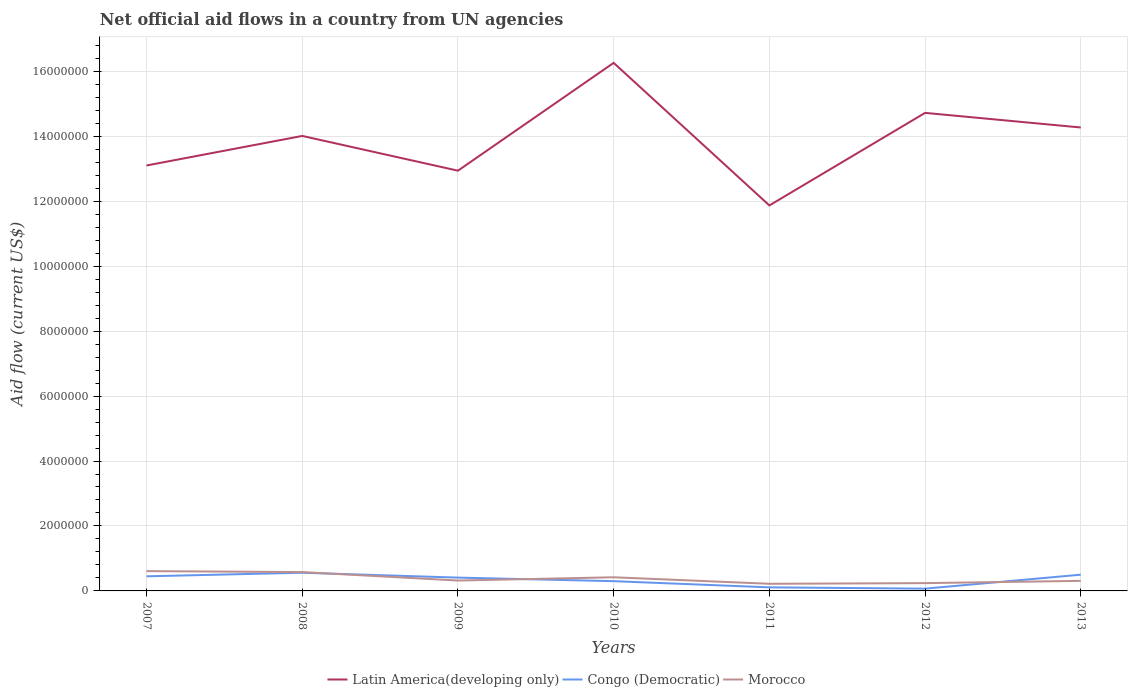Across all years, what is the maximum net official aid flow in Morocco?
Your response must be concise. 2.20e+05. What is the total net official aid flow in Latin America(developing only) in the graph?
Your response must be concise. 4.50e+05. What is the difference between the highest and the second highest net official aid flow in Congo (Democratic)?
Make the answer very short. 4.90e+05. What is the difference between the highest and the lowest net official aid flow in Latin America(developing only)?
Make the answer very short. 4. How many years are there in the graph?
Your answer should be very brief. 7. What is the difference between two consecutive major ticks on the Y-axis?
Your answer should be compact. 2.00e+06. Are the values on the major ticks of Y-axis written in scientific E-notation?
Ensure brevity in your answer.  No. Does the graph contain grids?
Keep it short and to the point. Yes. Where does the legend appear in the graph?
Offer a very short reply. Bottom center. What is the title of the graph?
Your answer should be very brief. Net official aid flows in a country from UN agencies. What is the label or title of the X-axis?
Provide a succinct answer. Years. What is the Aid flow (current US$) of Latin America(developing only) in 2007?
Your response must be concise. 1.31e+07. What is the Aid flow (current US$) in Latin America(developing only) in 2008?
Give a very brief answer. 1.40e+07. What is the Aid flow (current US$) in Congo (Democratic) in 2008?
Ensure brevity in your answer.  5.60e+05. What is the Aid flow (current US$) in Morocco in 2008?
Your response must be concise. 5.80e+05. What is the Aid flow (current US$) in Latin America(developing only) in 2009?
Offer a terse response. 1.29e+07. What is the Aid flow (current US$) in Latin America(developing only) in 2010?
Provide a short and direct response. 1.63e+07. What is the Aid flow (current US$) of Congo (Democratic) in 2010?
Offer a very short reply. 3.00e+05. What is the Aid flow (current US$) of Morocco in 2010?
Ensure brevity in your answer.  4.20e+05. What is the Aid flow (current US$) in Latin America(developing only) in 2011?
Your answer should be compact. 1.19e+07. What is the Aid flow (current US$) of Latin America(developing only) in 2012?
Provide a succinct answer. 1.47e+07. What is the Aid flow (current US$) in Latin America(developing only) in 2013?
Offer a terse response. 1.43e+07. What is the Aid flow (current US$) in Morocco in 2013?
Provide a short and direct response. 3.10e+05. Across all years, what is the maximum Aid flow (current US$) of Latin America(developing only)?
Offer a terse response. 1.63e+07. Across all years, what is the maximum Aid flow (current US$) of Congo (Democratic)?
Your response must be concise. 5.60e+05. Across all years, what is the maximum Aid flow (current US$) in Morocco?
Your answer should be very brief. 6.10e+05. Across all years, what is the minimum Aid flow (current US$) in Latin America(developing only)?
Provide a short and direct response. 1.19e+07. Across all years, what is the minimum Aid flow (current US$) of Congo (Democratic)?
Your answer should be compact. 7.00e+04. What is the total Aid flow (current US$) in Latin America(developing only) in the graph?
Offer a terse response. 9.72e+07. What is the total Aid flow (current US$) of Congo (Democratic) in the graph?
Ensure brevity in your answer.  2.40e+06. What is the total Aid flow (current US$) in Morocco in the graph?
Provide a succinct answer. 2.70e+06. What is the difference between the Aid flow (current US$) of Latin America(developing only) in 2007 and that in 2008?
Your answer should be very brief. -9.10e+05. What is the difference between the Aid flow (current US$) of Congo (Democratic) in 2007 and that in 2008?
Offer a very short reply. -1.10e+05. What is the difference between the Aid flow (current US$) in Morocco in 2007 and that in 2008?
Make the answer very short. 3.00e+04. What is the difference between the Aid flow (current US$) in Morocco in 2007 and that in 2009?
Offer a terse response. 2.90e+05. What is the difference between the Aid flow (current US$) of Latin America(developing only) in 2007 and that in 2010?
Ensure brevity in your answer.  -3.16e+06. What is the difference between the Aid flow (current US$) of Morocco in 2007 and that in 2010?
Your answer should be very brief. 1.90e+05. What is the difference between the Aid flow (current US$) in Latin America(developing only) in 2007 and that in 2011?
Offer a very short reply. 1.23e+06. What is the difference between the Aid flow (current US$) in Morocco in 2007 and that in 2011?
Give a very brief answer. 3.90e+05. What is the difference between the Aid flow (current US$) of Latin America(developing only) in 2007 and that in 2012?
Offer a very short reply. -1.62e+06. What is the difference between the Aid flow (current US$) of Morocco in 2007 and that in 2012?
Your answer should be very brief. 3.70e+05. What is the difference between the Aid flow (current US$) in Latin America(developing only) in 2007 and that in 2013?
Offer a very short reply. -1.17e+06. What is the difference between the Aid flow (current US$) of Latin America(developing only) in 2008 and that in 2009?
Ensure brevity in your answer.  1.07e+06. What is the difference between the Aid flow (current US$) of Congo (Democratic) in 2008 and that in 2009?
Ensure brevity in your answer.  1.50e+05. What is the difference between the Aid flow (current US$) in Morocco in 2008 and that in 2009?
Your answer should be compact. 2.60e+05. What is the difference between the Aid flow (current US$) in Latin America(developing only) in 2008 and that in 2010?
Make the answer very short. -2.25e+06. What is the difference between the Aid flow (current US$) of Congo (Democratic) in 2008 and that in 2010?
Provide a succinct answer. 2.60e+05. What is the difference between the Aid flow (current US$) in Morocco in 2008 and that in 2010?
Keep it short and to the point. 1.60e+05. What is the difference between the Aid flow (current US$) in Latin America(developing only) in 2008 and that in 2011?
Your response must be concise. 2.14e+06. What is the difference between the Aid flow (current US$) in Congo (Democratic) in 2008 and that in 2011?
Provide a short and direct response. 4.50e+05. What is the difference between the Aid flow (current US$) in Morocco in 2008 and that in 2011?
Offer a very short reply. 3.60e+05. What is the difference between the Aid flow (current US$) of Latin America(developing only) in 2008 and that in 2012?
Your response must be concise. -7.10e+05. What is the difference between the Aid flow (current US$) of Congo (Democratic) in 2008 and that in 2013?
Your answer should be compact. 6.00e+04. What is the difference between the Aid flow (current US$) in Morocco in 2008 and that in 2013?
Your answer should be compact. 2.70e+05. What is the difference between the Aid flow (current US$) in Latin America(developing only) in 2009 and that in 2010?
Provide a short and direct response. -3.32e+06. What is the difference between the Aid flow (current US$) of Latin America(developing only) in 2009 and that in 2011?
Make the answer very short. 1.07e+06. What is the difference between the Aid flow (current US$) of Latin America(developing only) in 2009 and that in 2012?
Your response must be concise. -1.78e+06. What is the difference between the Aid flow (current US$) in Latin America(developing only) in 2009 and that in 2013?
Provide a short and direct response. -1.33e+06. What is the difference between the Aid flow (current US$) in Congo (Democratic) in 2009 and that in 2013?
Your answer should be compact. -9.00e+04. What is the difference between the Aid flow (current US$) of Latin America(developing only) in 2010 and that in 2011?
Your answer should be compact. 4.39e+06. What is the difference between the Aid flow (current US$) in Morocco in 2010 and that in 2011?
Make the answer very short. 2.00e+05. What is the difference between the Aid flow (current US$) in Latin America(developing only) in 2010 and that in 2012?
Your response must be concise. 1.54e+06. What is the difference between the Aid flow (current US$) of Morocco in 2010 and that in 2012?
Offer a very short reply. 1.80e+05. What is the difference between the Aid flow (current US$) of Latin America(developing only) in 2010 and that in 2013?
Offer a very short reply. 1.99e+06. What is the difference between the Aid flow (current US$) in Congo (Democratic) in 2010 and that in 2013?
Ensure brevity in your answer.  -2.00e+05. What is the difference between the Aid flow (current US$) in Morocco in 2010 and that in 2013?
Your answer should be very brief. 1.10e+05. What is the difference between the Aid flow (current US$) in Latin America(developing only) in 2011 and that in 2012?
Give a very brief answer. -2.85e+06. What is the difference between the Aid flow (current US$) in Congo (Democratic) in 2011 and that in 2012?
Ensure brevity in your answer.  4.00e+04. What is the difference between the Aid flow (current US$) of Morocco in 2011 and that in 2012?
Your answer should be very brief. -2.00e+04. What is the difference between the Aid flow (current US$) of Latin America(developing only) in 2011 and that in 2013?
Offer a terse response. -2.40e+06. What is the difference between the Aid flow (current US$) in Congo (Democratic) in 2011 and that in 2013?
Keep it short and to the point. -3.90e+05. What is the difference between the Aid flow (current US$) of Morocco in 2011 and that in 2013?
Your response must be concise. -9.00e+04. What is the difference between the Aid flow (current US$) in Latin America(developing only) in 2012 and that in 2013?
Keep it short and to the point. 4.50e+05. What is the difference between the Aid flow (current US$) of Congo (Democratic) in 2012 and that in 2013?
Give a very brief answer. -4.30e+05. What is the difference between the Aid flow (current US$) in Morocco in 2012 and that in 2013?
Provide a succinct answer. -7.00e+04. What is the difference between the Aid flow (current US$) in Latin America(developing only) in 2007 and the Aid flow (current US$) in Congo (Democratic) in 2008?
Your answer should be very brief. 1.25e+07. What is the difference between the Aid flow (current US$) in Latin America(developing only) in 2007 and the Aid flow (current US$) in Morocco in 2008?
Give a very brief answer. 1.25e+07. What is the difference between the Aid flow (current US$) of Congo (Democratic) in 2007 and the Aid flow (current US$) of Morocco in 2008?
Provide a short and direct response. -1.30e+05. What is the difference between the Aid flow (current US$) of Latin America(developing only) in 2007 and the Aid flow (current US$) of Congo (Democratic) in 2009?
Provide a succinct answer. 1.27e+07. What is the difference between the Aid flow (current US$) in Latin America(developing only) in 2007 and the Aid flow (current US$) in Morocco in 2009?
Make the answer very short. 1.28e+07. What is the difference between the Aid flow (current US$) in Congo (Democratic) in 2007 and the Aid flow (current US$) in Morocco in 2009?
Offer a terse response. 1.30e+05. What is the difference between the Aid flow (current US$) of Latin America(developing only) in 2007 and the Aid flow (current US$) of Congo (Democratic) in 2010?
Make the answer very short. 1.28e+07. What is the difference between the Aid flow (current US$) in Latin America(developing only) in 2007 and the Aid flow (current US$) in Morocco in 2010?
Provide a succinct answer. 1.27e+07. What is the difference between the Aid flow (current US$) of Congo (Democratic) in 2007 and the Aid flow (current US$) of Morocco in 2010?
Offer a terse response. 3.00e+04. What is the difference between the Aid flow (current US$) in Latin America(developing only) in 2007 and the Aid flow (current US$) in Congo (Democratic) in 2011?
Your answer should be compact. 1.30e+07. What is the difference between the Aid flow (current US$) of Latin America(developing only) in 2007 and the Aid flow (current US$) of Morocco in 2011?
Your response must be concise. 1.29e+07. What is the difference between the Aid flow (current US$) in Latin America(developing only) in 2007 and the Aid flow (current US$) in Congo (Democratic) in 2012?
Provide a succinct answer. 1.30e+07. What is the difference between the Aid flow (current US$) of Latin America(developing only) in 2007 and the Aid flow (current US$) of Morocco in 2012?
Provide a short and direct response. 1.29e+07. What is the difference between the Aid flow (current US$) in Congo (Democratic) in 2007 and the Aid flow (current US$) in Morocco in 2012?
Your response must be concise. 2.10e+05. What is the difference between the Aid flow (current US$) of Latin America(developing only) in 2007 and the Aid flow (current US$) of Congo (Democratic) in 2013?
Keep it short and to the point. 1.26e+07. What is the difference between the Aid flow (current US$) in Latin America(developing only) in 2007 and the Aid flow (current US$) in Morocco in 2013?
Offer a very short reply. 1.28e+07. What is the difference between the Aid flow (current US$) of Congo (Democratic) in 2007 and the Aid flow (current US$) of Morocco in 2013?
Offer a very short reply. 1.40e+05. What is the difference between the Aid flow (current US$) in Latin America(developing only) in 2008 and the Aid flow (current US$) in Congo (Democratic) in 2009?
Offer a very short reply. 1.36e+07. What is the difference between the Aid flow (current US$) of Latin America(developing only) in 2008 and the Aid flow (current US$) of Morocco in 2009?
Keep it short and to the point. 1.37e+07. What is the difference between the Aid flow (current US$) in Latin America(developing only) in 2008 and the Aid flow (current US$) in Congo (Democratic) in 2010?
Keep it short and to the point. 1.37e+07. What is the difference between the Aid flow (current US$) in Latin America(developing only) in 2008 and the Aid flow (current US$) in Morocco in 2010?
Make the answer very short. 1.36e+07. What is the difference between the Aid flow (current US$) of Latin America(developing only) in 2008 and the Aid flow (current US$) of Congo (Democratic) in 2011?
Your response must be concise. 1.39e+07. What is the difference between the Aid flow (current US$) of Latin America(developing only) in 2008 and the Aid flow (current US$) of Morocco in 2011?
Make the answer very short. 1.38e+07. What is the difference between the Aid flow (current US$) in Congo (Democratic) in 2008 and the Aid flow (current US$) in Morocco in 2011?
Your answer should be compact. 3.40e+05. What is the difference between the Aid flow (current US$) of Latin America(developing only) in 2008 and the Aid flow (current US$) of Congo (Democratic) in 2012?
Give a very brief answer. 1.39e+07. What is the difference between the Aid flow (current US$) in Latin America(developing only) in 2008 and the Aid flow (current US$) in Morocco in 2012?
Offer a very short reply. 1.38e+07. What is the difference between the Aid flow (current US$) of Latin America(developing only) in 2008 and the Aid flow (current US$) of Congo (Democratic) in 2013?
Provide a short and direct response. 1.35e+07. What is the difference between the Aid flow (current US$) of Latin America(developing only) in 2008 and the Aid flow (current US$) of Morocco in 2013?
Your answer should be compact. 1.37e+07. What is the difference between the Aid flow (current US$) in Latin America(developing only) in 2009 and the Aid flow (current US$) in Congo (Democratic) in 2010?
Your answer should be compact. 1.26e+07. What is the difference between the Aid flow (current US$) of Latin America(developing only) in 2009 and the Aid flow (current US$) of Morocco in 2010?
Give a very brief answer. 1.25e+07. What is the difference between the Aid flow (current US$) of Latin America(developing only) in 2009 and the Aid flow (current US$) of Congo (Democratic) in 2011?
Your answer should be very brief. 1.28e+07. What is the difference between the Aid flow (current US$) in Latin America(developing only) in 2009 and the Aid flow (current US$) in Morocco in 2011?
Provide a short and direct response. 1.27e+07. What is the difference between the Aid flow (current US$) in Latin America(developing only) in 2009 and the Aid flow (current US$) in Congo (Democratic) in 2012?
Offer a terse response. 1.29e+07. What is the difference between the Aid flow (current US$) of Latin America(developing only) in 2009 and the Aid flow (current US$) of Morocco in 2012?
Keep it short and to the point. 1.27e+07. What is the difference between the Aid flow (current US$) in Latin America(developing only) in 2009 and the Aid flow (current US$) in Congo (Democratic) in 2013?
Offer a very short reply. 1.24e+07. What is the difference between the Aid flow (current US$) in Latin America(developing only) in 2009 and the Aid flow (current US$) in Morocco in 2013?
Make the answer very short. 1.26e+07. What is the difference between the Aid flow (current US$) in Latin America(developing only) in 2010 and the Aid flow (current US$) in Congo (Democratic) in 2011?
Offer a terse response. 1.62e+07. What is the difference between the Aid flow (current US$) of Latin America(developing only) in 2010 and the Aid flow (current US$) of Morocco in 2011?
Your response must be concise. 1.60e+07. What is the difference between the Aid flow (current US$) of Latin America(developing only) in 2010 and the Aid flow (current US$) of Congo (Democratic) in 2012?
Provide a succinct answer. 1.62e+07. What is the difference between the Aid flow (current US$) in Latin America(developing only) in 2010 and the Aid flow (current US$) in Morocco in 2012?
Your response must be concise. 1.60e+07. What is the difference between the Aid flow (current US$) of Congo (Democratic) in 2010 and the Aid flow (current US$) of Morocco in 2012?
Make the answer very short. 6.00e+04. What is the difference between the Aid flow (current US$) in Latin America(developing only) in 2010 and the Aid flow (current US$) in Congo (Democratic) in 2013?
Give a very brief answer. 1.58e+07. What is the difference between the Aid flow (current US$) of Latin America(developing only) in 2010 and the Aid flow (current US$) of Morocco in 2013?
Your response must be concise. 1.60e+07. What is the difference between the Aid flow (current US$) in Congo (Democratic) in 2010 and the Aid flow (current US$) in Morocco in 2013?
Provide a short and direct response. -10000. What is the difference between the Aid flow (current US$) of Latin America(developing only) in 2011 and the Aid flow (current US$) of Congo (Democratic) in 2012?
Ensure brevity in your answer.  1.18e+07. What is the difference between the Aid flow (current US$) of Latin America(developing only) in 2011 and the Aid flow (current US$) of Morocco in 2012?
Offer a terse response. 1.16e+07. What is the difference between the Aid flow (current US$) of Latin America(developing only) in 2011 and the Aid flow (current US$) of Congo (Democratic) in 2013?
Your answer should be very brief. 1.14e+07. What is the difference between the Aid flow (current US$) of Latin America(developing only) in 2011 and the Aid flow (current US$) of Morocco in 2013?
Offer a terse response. 1.16e+07. What is the difference between the Aid flow (current US$) in Congo (Democratic) in 2011 and the Aid flow (current US$) in Morocco in 2013?
Your answer should be very brief. -2.00e+05. What is the difference between the Aid flow (current US$) of Latin America(developing only) in 2012 and the Aid flow (current US$) of Congo (Democratic) in 2013?
Ensure brevity in your answer.  1.42e+07. What is the difference between the Aid flow (current US$) of Latin America(developing only) in 2012 and the Aid flow (current US$) of Morocco in 2013?
Your answer should be compact. 1.44e+07. What is the average Aid flow (current US$) in Latin America(developing only) per year?
Your answer should be compact. 1.39e+07. What is the average Aid flow (current US$) in Congo (Democratic) per year?
Your answer should be compact. 3.43e+05. What is the average Aid flow (current US$) in Morocco per year?
Offer a terse response. 3.86e+05. In the year 2007, what is the difference between the Aid flow (current US$) of Latin America(developing only) and Aid flow (current US$) of Congo (Democratic)?
Your response must be concise. 1.26e+07. In the year 2007, what is the difference between the Aid flow (current US$) of Latin America(developing only) and Aid flow (current US$) of Morocco?
Provide a short and direct response. 1.25e+07. In the year 2007, what is the difference between the Aid flow (current US$) in Congo (Democratic) and Aid flow (current US$) in Morocco?
Provide a short and direct response. -1.60e+05. In the year 2008, what is the difference between the Aid flow (current US$) of Latin America(developing only) and Aid flow (current US$) of Congo (Democratic)?
Offer a very short reply. 1.34e+07. In the year 2008, what is the difference between the Aid flow (current US$) of Latin America(developing only) and Aid flow (current US$) of Morocco?
Keep it short and to the point. 1.34e+07. In the year 2008, what is the difference between the Aid flow (current US$) in Congo (Democratic) and Aid flow (current US$) in Morocco?
Your answer should be very brief. -2.00e+04. In the year 2009, what is the difference between the Aid flow (current US$) in Latin America(developing only) and Aid flow (current US$) in Congo (Democratic)?
Keep it short and to the point. 1.25e+07. In the year 2009, what is the difference between the Aid flow (current US$) in Latin America(developing only) and Aid flow (current US$) in Morocco?
Provide a short and direct response. 1.26e+07. In the year 2010, what is the difference between the Aid flow (current US$) in Latin America(developing only) and Aid flow (current US$) in Congo (Democratic)?
Your answer should be very brief. 1.60e+07. In the year 2010, what is the difference between the Aid flow (current US$) of Latin America(developing only) and Aid flow (current US$) of Morocco?
Your response must be concise. 1.58e+07. In the year 2010, what is the difference between the Aid flow (current US$) in Congo (Democratic) and Aid flow (current US$) in Morocco?
Keep it short and to the point. -1.20e+05. In the year 2011, what is the difference between the Aid flow (current US$) of Latin America(developing only) and Aid flow (current US$) of Congo (Democratic)?
Your answer should be compact. 1.18e+07. In the year 2011, what is the difference between the Aid flow (current US$) in Latin America(developing only) and Aid flow (current US$) in Morocco?
Keep it short and to the point. 1.16e+07. In the year 2012, what is the difference between the Aid flow (current US$) in Latin America(developing only) and Aid flow (current US$) in Congo (Democratic)?
Offer a very short reply. 1.46e+07. In the year 2012, what is the difference between the Aid flow (current US$) in Latin America(developing only) and Aid flow (current US$) in Morocco?
Offer a terse response. 1.45e+07. In the year 2013, what is the difference between the Aid flow (current US$) in Latin America(developing only) and Aid flow (current US$) in Congo (Democratic)?
Keep it short and to the point. 1.38e+07. In the year 2013, what is the difference between the Aid flow (current US$) in Latin America(developing only) and Aid flow (current US$) in Morocco?
Ensure brevity in your answer.  1.40e+07. What is the ratio of the Aid flow (current US$) in Latin America(developing only) in 2007 to that in 2008?
Keep it short and to the point. 0.94. What is the ratio of the Aid flow (current US$) in Congo (Democratic) in 2007 to that in 2008?
Your answer should be compact. 0.8. What is the ratio of the Aid flow (current US$) in Morocco in 2007 to that in 2008?
Make the answer very short. 1.05. What is the ratio of the Aid flow (current US$) of Latin America(developing only) in 2007 to that in 2009?
Offer a terse response. 1.01. What is the ratio of the Aid flow (current US$) in Congo (Democratic) in 2007 to that in 2009?
Your answer should be compact. 1.1. What is the ratio of the Aid flow (current US$) in Morocco in 2007 to that in 2009?
Make the answer very short. 1.91. What is the ratio of the Aid flow (current US$) of Latin America(developing only) in 2007 to that in 2010?
Ensure brevity in your answer.  0.81. What is the ratio of the Aid flow (current US$) of Morocco in 2007 to that in 2010?
Your answer should be compact. 1.45. What is the ratio of the Aid flow (current US$) in Latin America(developing only) in 2007 to that in 2011?
Your answer should be compact. 1.1. What is the ratio of the Aid flow (current US$) in Congo (Democratic) in 2007 to that in 2011?
Give a very brief answer. 4.09. What is the ratio of the Aid flow (current US$) of Morocco in 2007 to that in 2011?
Make the answer very short. 2.77. What is the ratio of the Aid flow (current US$) in Latin America(developing only) in 2007 to that in 2012?
Ensure brevity in your answer.  0.89. What is the ratio of the Aid flow (current US$) in Congo (Democratic) in 2007 to that in 2012?
Ensure brevity in your answer.  6.43. What is the ratio of the Aid flow (current US$) in Morocco in 2007 to that in 2012?
Provide a short and direct response. 2.54. What is the ratio of the Aid flow (current US$) of Latin America(developing only) in 2007 to that in 2013?
Give a very brief answer. 0.92. What is the ratio of the Aid flow (current US$) in Morocco in 2007 to that in 2013?
Your answer should be very brief. 1.97. What is the ratio of the Aid flow (current US$) of Latin America(developing only) in 2008 to that in 2009?
Your answer should be very brief. 1.08. What is the ratio of the Aid flow (current US$) in Congo (Democratic) in 2008 to that in 2009?
Provide a short and direct response. 1.37. What is the ratio of the Aid flow (current US$) in Morocco in 2008 to that in 2009?
Make the answer very short. 1.81. What is the ratio of the Aid flow (current US$) in Latin America(developing only) in 2008 to that in 2010?
Offer a very short reply. 0.86. What is the ratio of the Aid flow (current US$) of Congo (Democratic) in 2008 to that in 2010?
Keep it short and to the point. 1.87. What is the ratio of the Aid flow (current US$) of Morocco in 2008 to that in 2010?
Give a very brief answer. 1.38. What is the ratio of the Aid flow (current US$) in Latin America(developing only) in 2008 to that in 2011?
Offer a terse response. 1.18. What is the ratio of the Aid flow (current US$) in Congo (Democratic) in 2008 to that in 2011?
Keep it short and to the point. 5.09. What is the ratio of the Aid flow (current US$) in Morocco in 2008 to that in 2011?
Provide a succinct answer. 2.64. What is the ratio of the Aid flow (current US$) of Latin America(developing only) in 2008 to that in 2012?
Give a very brief answer. 0.95. What is the ratio of the Aid flow (current US$) of Morocco in 2008 to that in 2012?
Offer a terse response. 2.42. What is the ratio of the Aid flow (current US$) of Latin America(developing only) in 2008 to that in 2013?
Ensure brevity in your answer.  0.98. What is the ratio of the Aid flow (current US$) in Congo (Democratic) in 2008 to that in 2013?
Keep it short and to the point. 1.12. What is the ratio of the Aid flow (current US$) of Morocco in 2008 to that in 2013?
Offer a terse response. 1.87. What is the ratio of the Aid flow (current US$) in Latin America(developing only) in 2009 to that in 2010?
Give a very brief answer. 0.8. What is the ratio of the Aid flow (current US$) of Congo (Democratic) in 2009 to that in 2010?
Keep it short and to the point. 1.37. What is the ratio of the Aid flow (current US$) in Morocco in 2009 to that in 2010?
Provide a succinct answer. 0.76. What is the ratio of the Aid flow (current US$) in Latin America(developing only) in 2009 to that in 2011?
Provide a succinct answer. 1.09. What is the ratio of the Aid flow (current US$) in Congo (Democratic) in 2009 to that in 2011?
Your response must be concise. 3.73. What is the ratio of the Aid flow (current US$) in Morocco in 2009 to that in 2011?
Ensure brevity in your answer.  1.45. What is the ratio of the Aid flow (current US$) in Latin America(developing only) in 2009 to that in 2012?
Your response must be concise. 0.88. What is the ratio of the Aid flow (current US$) of Congo (Democratic) in 2009 to that in 2012?
Offer a very short reply. 5.86. What is the ratio of the Aid flow (current US$) of Latin America(developing only) in 2009 to that in 2013?
Offer a very short reply. 0.91. What is the ratio of the Aid flow (current US$) in Congo (Democratic) in 2009 to that in 2013?
Offer a terse response. 0.82. What is the ratio of the Aid flow (current US$) of Morocco in 2009 to that in 2013?
Ensure brevity in your answer.  1.03. What is the ratio of the Aid flow (current US$) in Latin America(developing only) in 2010 to that in 2011?
Make the answer very short. 1.37. What is the ratio of the Aid flow (current US$) in Congo (Democratic) in 2010 to that in 2011?
Offer a terse response. 2.73. What is the ratio of the Aid flow (current US$) in Morocco in 2010 to that in 2011?
Your answer should be very brief. 1.91. What is the ratio of the Aid flow (current US$) of Latin America(developing only) in 2010 to that in 2012?
Keep it short and to the point. 1.1. What is the ratio of the Aid flow (current US$) in Congo (Democratic) in 2010 to that in 2012?
Give a very brief answer. 4.29. What is the ratio of the Aid flow (current US$) of Morocco in 2010 to that in 2012?
Offer a terse response. 1.75. What is the ratio of the Aid flow (current US$) in Latin America(developing only) in 2010 to that in 2013?
Keep it short and to the point. 1.14. What is the ratio of the Aid flow (current US$) of Congo (Democratic) in 2010 to that in 2013?
Provide a short and direct response. 0.6. What is the ratio of the Aid flow (current US$) in Morocco in 2010 to that in 2013?
Your answer should be very brief. 1.35. What is the ratio of the Aid flow (current US$) of Latin America(developing only) in 2011 to that in 2012?
Your answer should be very brief. 0.81. What is the ratio of the Aid flow (current US$) in Congo (Democratic) in 2011 to that in 2012?
Provide a short and direct response. 1.57. What is the ratio of the Aid flow (current US$) in Morocco in 2011 to that in 2012?
Provide a succinct answer. 0.92. What is the ratio of the Aid flow (current US$) in Latin America(developing only) in 2011 to that in 2013?
Offer a terse response. 0.83. What is the ratio of the Aid flow (current US$) of Congo (Democratic) in 2011 to that in 2013?
Keep it short and to the point. 0.22. What is the ratio of the Aid flow (current US$) in Morocco in 2011 to that in 2013?
Offer a very short reply. 0.71. What is the ratio of the Aid flow (current US$) of Latin America(developing only) in 2012 to that in 2013?
Provide a succinct answer. 1.03. What is the ratio of the Aid flow (current US$) in Congo (Democratic) in 2012 to that in 2013?
Provide a short and direct response. 0.14. What is the ratio of the Aid flow (current US$) in Morocco in 2012 to that in 2013?
Offer a very short reply. 0.77. What is the difference between the highest and the second highest Aid flow (current US$) of Latin America(developing only)?
Give a very brief answer. 1.54e+06. What is the difference between the highest and the second highest Aid flow (current US$) in Congo (Democratic)?
Offer a terse response. 6.00e+04. What is the difference between the highest and the second highest Aid flow (current US$) in Morocco?
Your answer should be compact. 3.00e+04. What is the difference between the highest and the lowest Aid flow (current US$) in Latin America(developing only)?
Offer a very short reply. 4.39e+06. What is the difference between the highest and the lowest Aid flow (current US$) of Morocco?
Offer a terse response. 3.90e+05. 